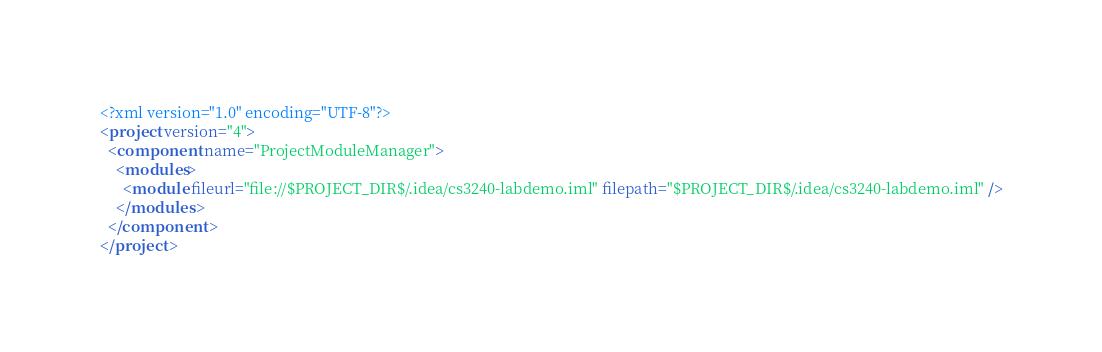<code> <loc_0><loc_0><loc_500><loc_500><_XML_><?xml version="1.0" encoding="UTF-8"?>
<project version="4">
  <component name="ProjectModuleManager">
    <modules>
      <module fileurl="file://$PROJECT_DIR$/.idea/cs3240-labdemo.iml" filepath="$PROJECT_DIR$/.idea/cs3240-labdemo.iml" />
    </modules>
  </component>
</project>

</code> 